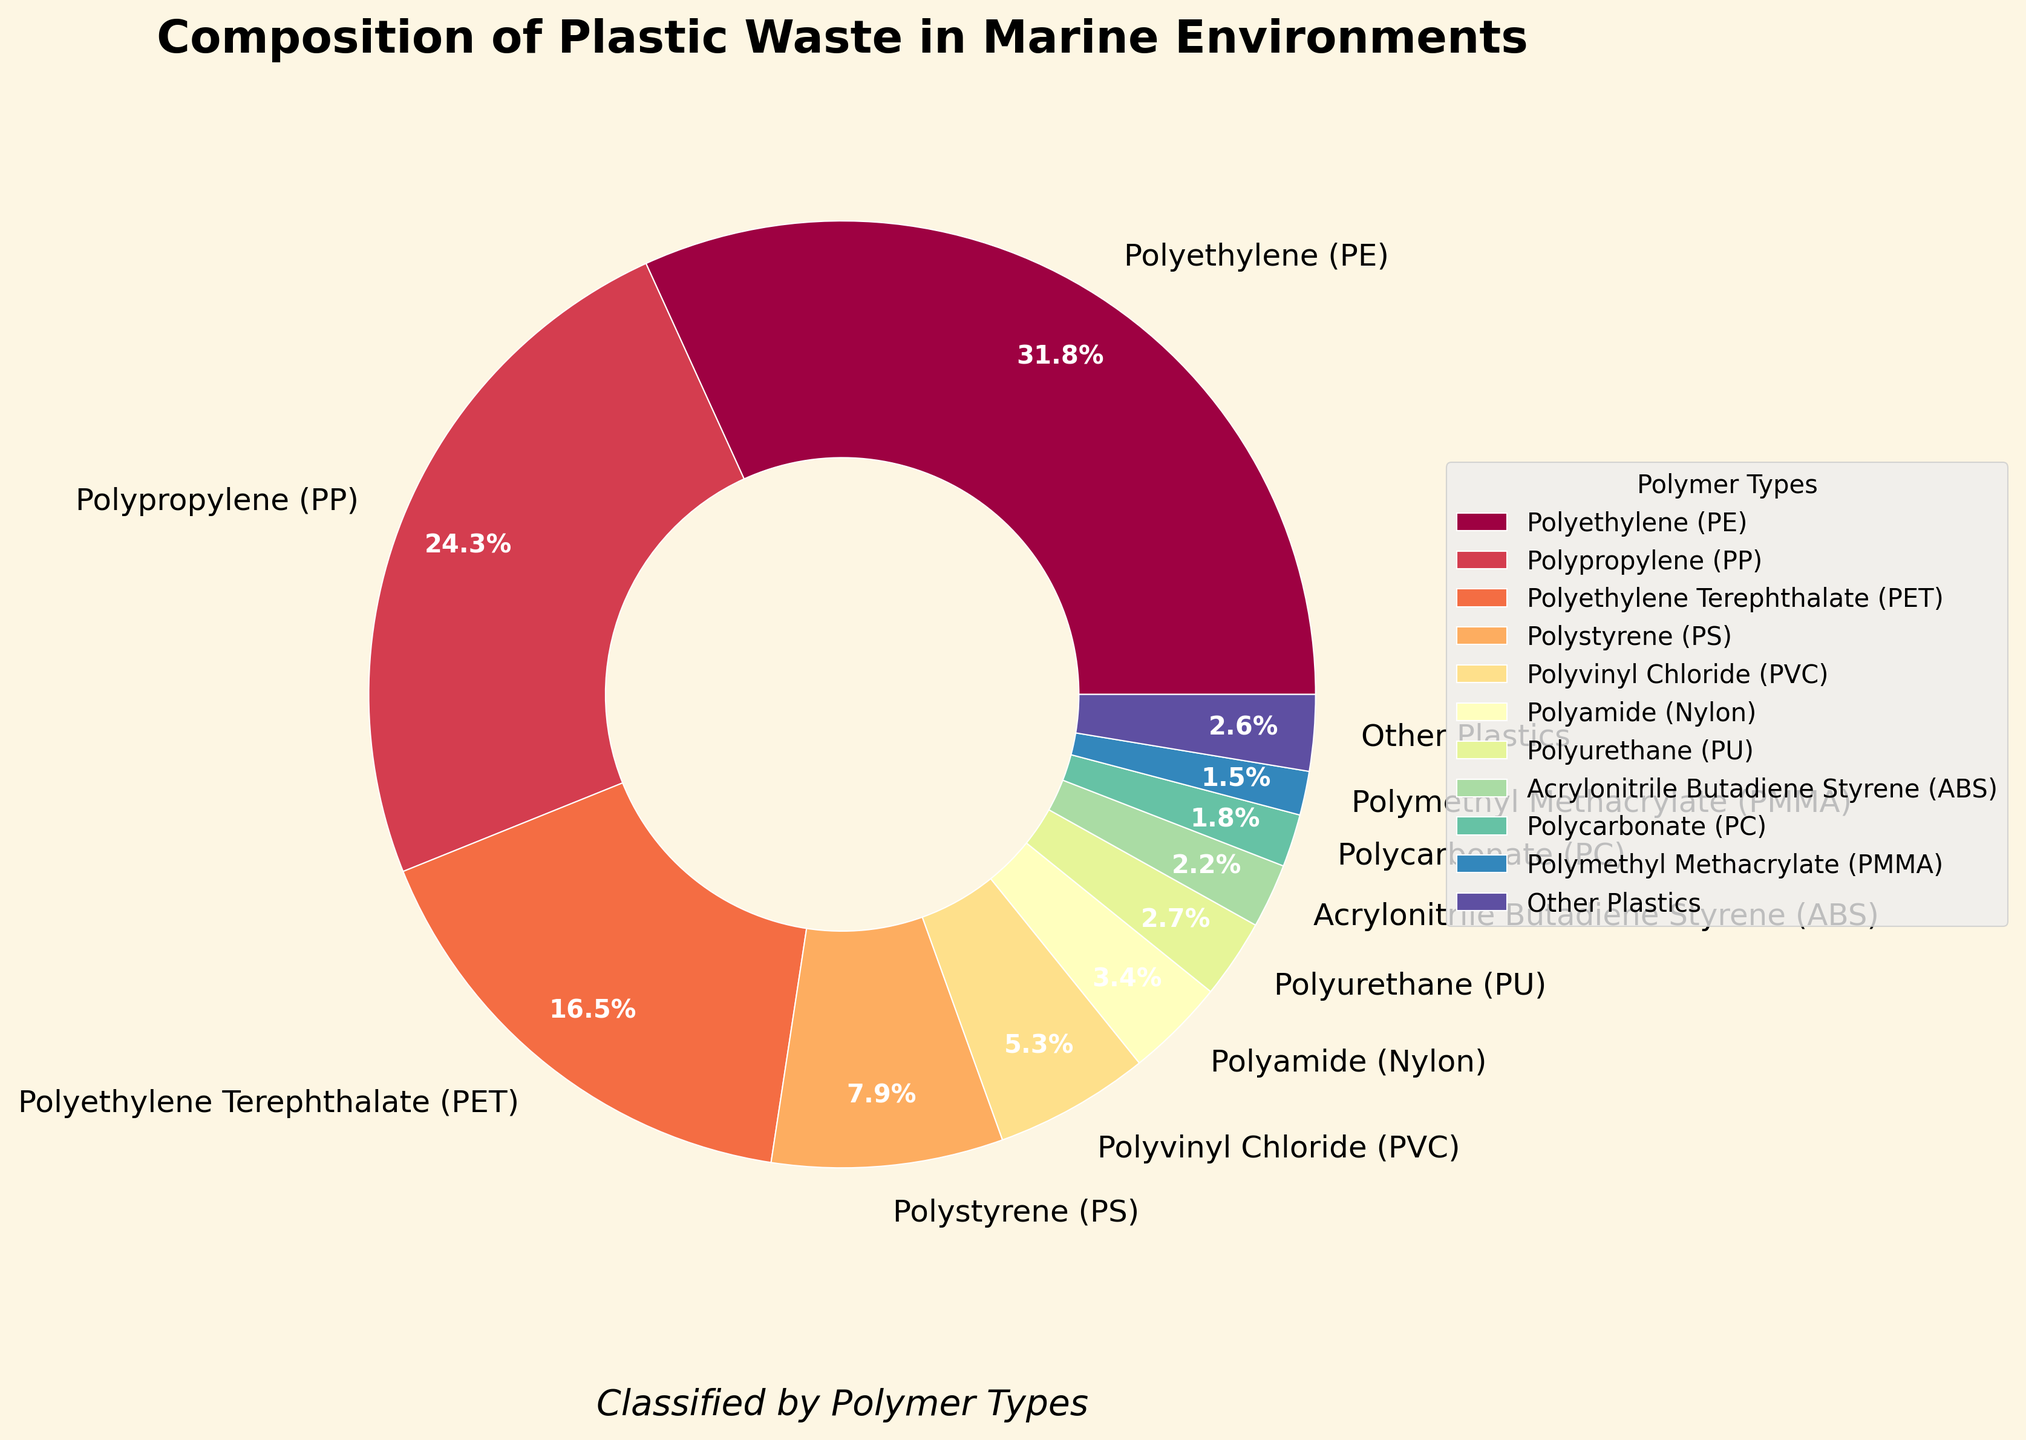What's the percentage of Polyethylene (PE) and Polypropylene (PP) combined? Polyethylene (PE) contributes 31.8% and Polypropylene (PP) contributes 24.3%. By adding them, we get 31.8% + 24.3% = 56.1%.
Answer: 56.1% Which polymer type has the highest percentage of plastic waste in marine environments? Among the polymer types listed, Polyethylene (PE) has the highest percentage at 31.8%.
Answer: Polyethylene (PE) Is Polyvinyl Chloride (PVC) represented in more or less than 10% of the composition? Polyvinyl Chloride (PVC) is shown to be 5.3%, which is less than 10%.
Answer: Less than 10% What is the difference in percentage between Polyethylene Terephthalate (PET) and Polystyrene (PS)? Polyethylene Terephthalate (PET) is 16.5% and Polystyrene (PS) is 7.9%. The difference is calculated as 16.5% - 7.9% = 8.6%.
Answer: 8.6% Which polymer types are represented with a percentage lower than 3%? According to the figure, Polyamide (Nylon) at 3.4%, Polyurethane (PU) at 2.7%, Acrylonitrile Butadiene Styrene (ABS) at 2.2%, Polycarbonate (PC) at 1.8%, and Polymethyl Methacrylate (PMMA) at 1.5% are lower than 3%.
Answer: Polyurethane (PU), Acrylonitrile Butadiene Styrene (ABS), Polycarbonate (PC), Polymethyl Methacrylate (PMMA) Is the total percentage of all listed polymer types exactly 100%? Sum up all percentages: 31.8% + 24.3% + 16.5% + 7.9% + 5.3% + 3.4% + 2.7% + 2.2% + 1.8% + 1.5% + 2.6% = 100%.
Answer: Yes How much higher is the percentage of Polypropylene (PP) compared to Polyvinyl Chloride (PVC)? Polypropylene (PP) is 24.3% and Polyvinyl Chloride (PVC) is 5.3%. The difference is 24.3% - 5.3% = 19%.
Answer: 19% Which polymer type is represented right after Polyethylene Terephthalate (PET) in the pie chart's legend sequence? Observing the sequence in the legend, Polystyrene (PS) follows Polyethylene Terephthalate (PET).
Answer: Polystyrene (PS) What is the total percentage for Polyamide (Nylon), Polyurethane (PU), and Polycarbonate (PC) combined? Adding percentages for Polyamide (Nylon) at 3.4%, Polyurethane (PU) at 2.7%, and Polycarbonate (PC) at 1.8%, we get 3.4% + 2.7% + 1.8% = 7.9%.
Answer: 7.9% What color is used to represent Polyethylene (PE) in the pie chart? According to the custom color palette and plot, Polyethylene (PE) is represented with the largest segment in a color ranging from the start of the color spectrum, typically some shade of red or orange in the Spectral color map.
Answer: Red/Orange 